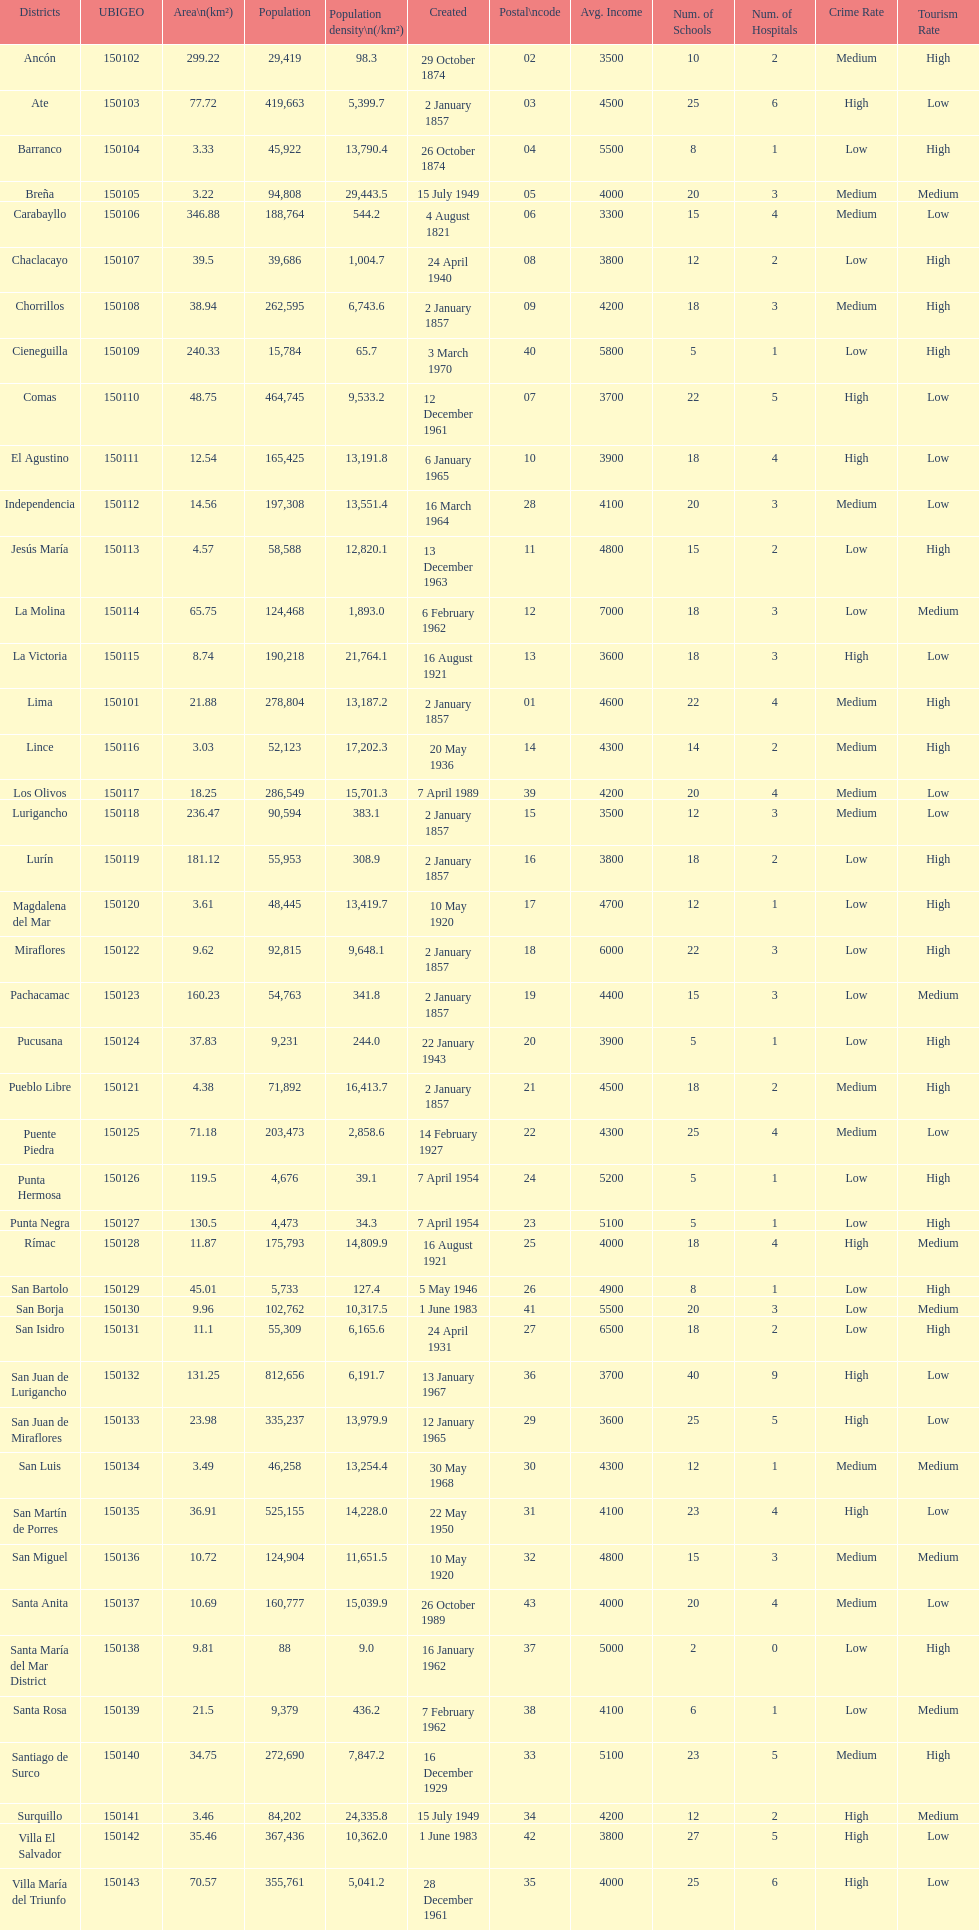What was the last district created? Santa Anita. 